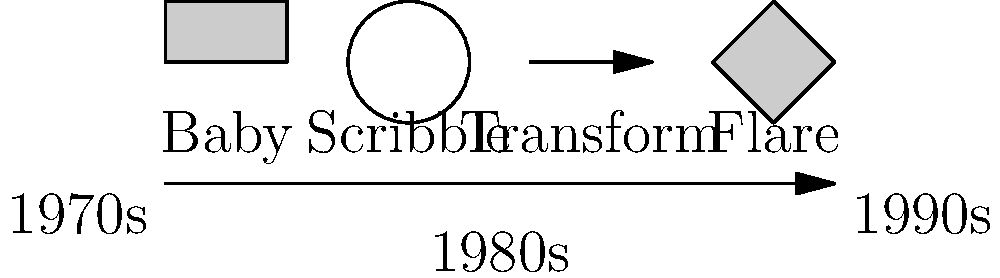Analyze the evolution of turntable techniques in hip-hop as illustrated in the diagram. Which scratch pattern, developed in the late 1980s, represented a significant advancement in complexity and is often associated with the "golden age" of turntablism? To answer this question, let's examine the evolution of turntable techniques in hip-hop as shown in the diagram:

1. Baby Scratch (1970s): This is the most basic scratch technique, involving moving the record back and forth in a simple pattern.

2. Scribble Scratch (Early 1980s): A more rapid version of the baby scratch, creating a "scribbling" sound effect.

3. Transform Scratch (Mid 1980s): This technique involves quickly alternating between two sound sources, creating a transforming effect.

4. Flare Scratch (Late 1980s): Developed by DJ Flare, this complex technique involves a combination of forward and backward movements with rhythmic clicks of the crossfader.

The Flare Scratch, introduced in the late 1980s, represented a significant advancement in complexity. It required precise coordination between record manipulation and crossfader control, allowing for more intricate rhythmic patterns and sound textures. This technique became prominent during what is often referred to as the "golden age" of hip-hop and turntablism (late 1980s to early 1990s).

The Flare Scratch opened up new possibilities for artistic expression in DJing, influencing the development of even more complex techniques in the 1990s and beyond. Its introduction marked a turning point in the evolution of turntablism, elevating the role of the DJ from a simple record player to a true musical performer and innovator.
Answer: Flare Scratch 